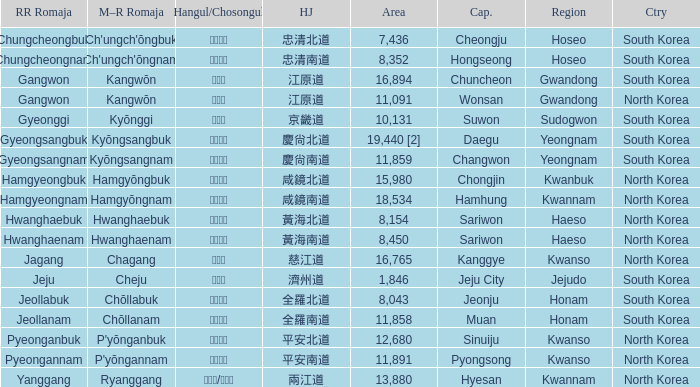What is the M-R Romaja for the province having a capital of Cheongju? Ch'ungch'ŏngbuk. 